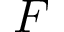Convert formula to latex. <formula><loc_0><loc_0><loc_500><loc_500>F</formula> 